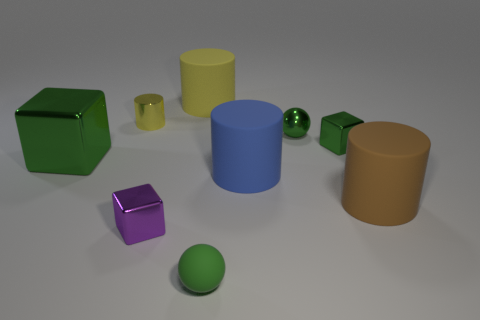There is a purple object that is made of the same material as the tiny green cube; what shape is it? The purple object that shares its material properties with the small green cube in the image is also shaped as a cube, showcasing clean, sharp corners and equal-length edges that are characteristic of cubic geometry. 